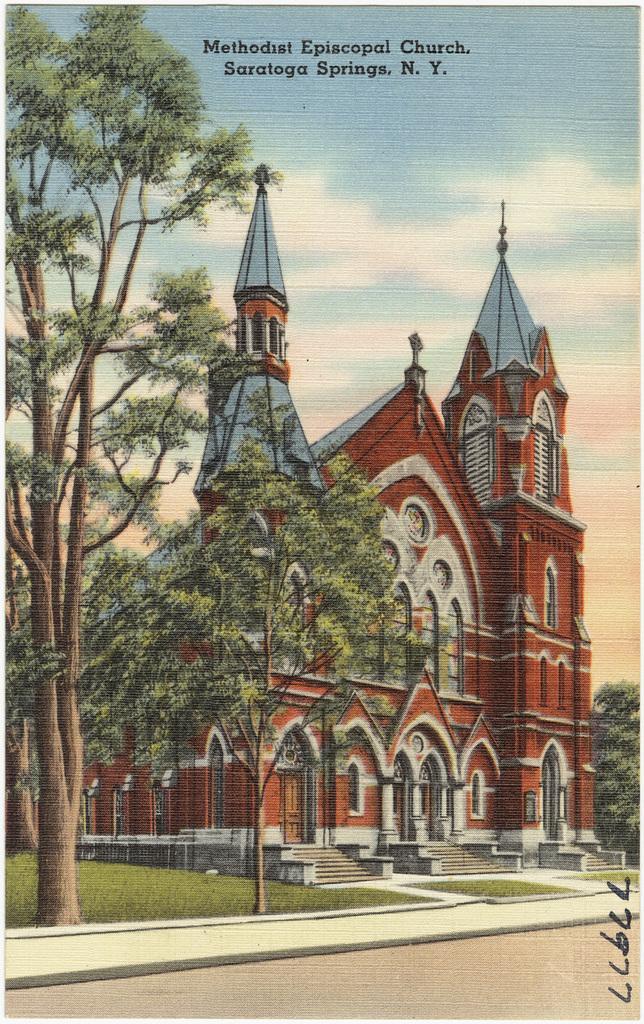Could you give a brief overview of what you see in this image? In this image there is a castle in the center and there are trees and there is grass on the ground and the sky is cloudy. 